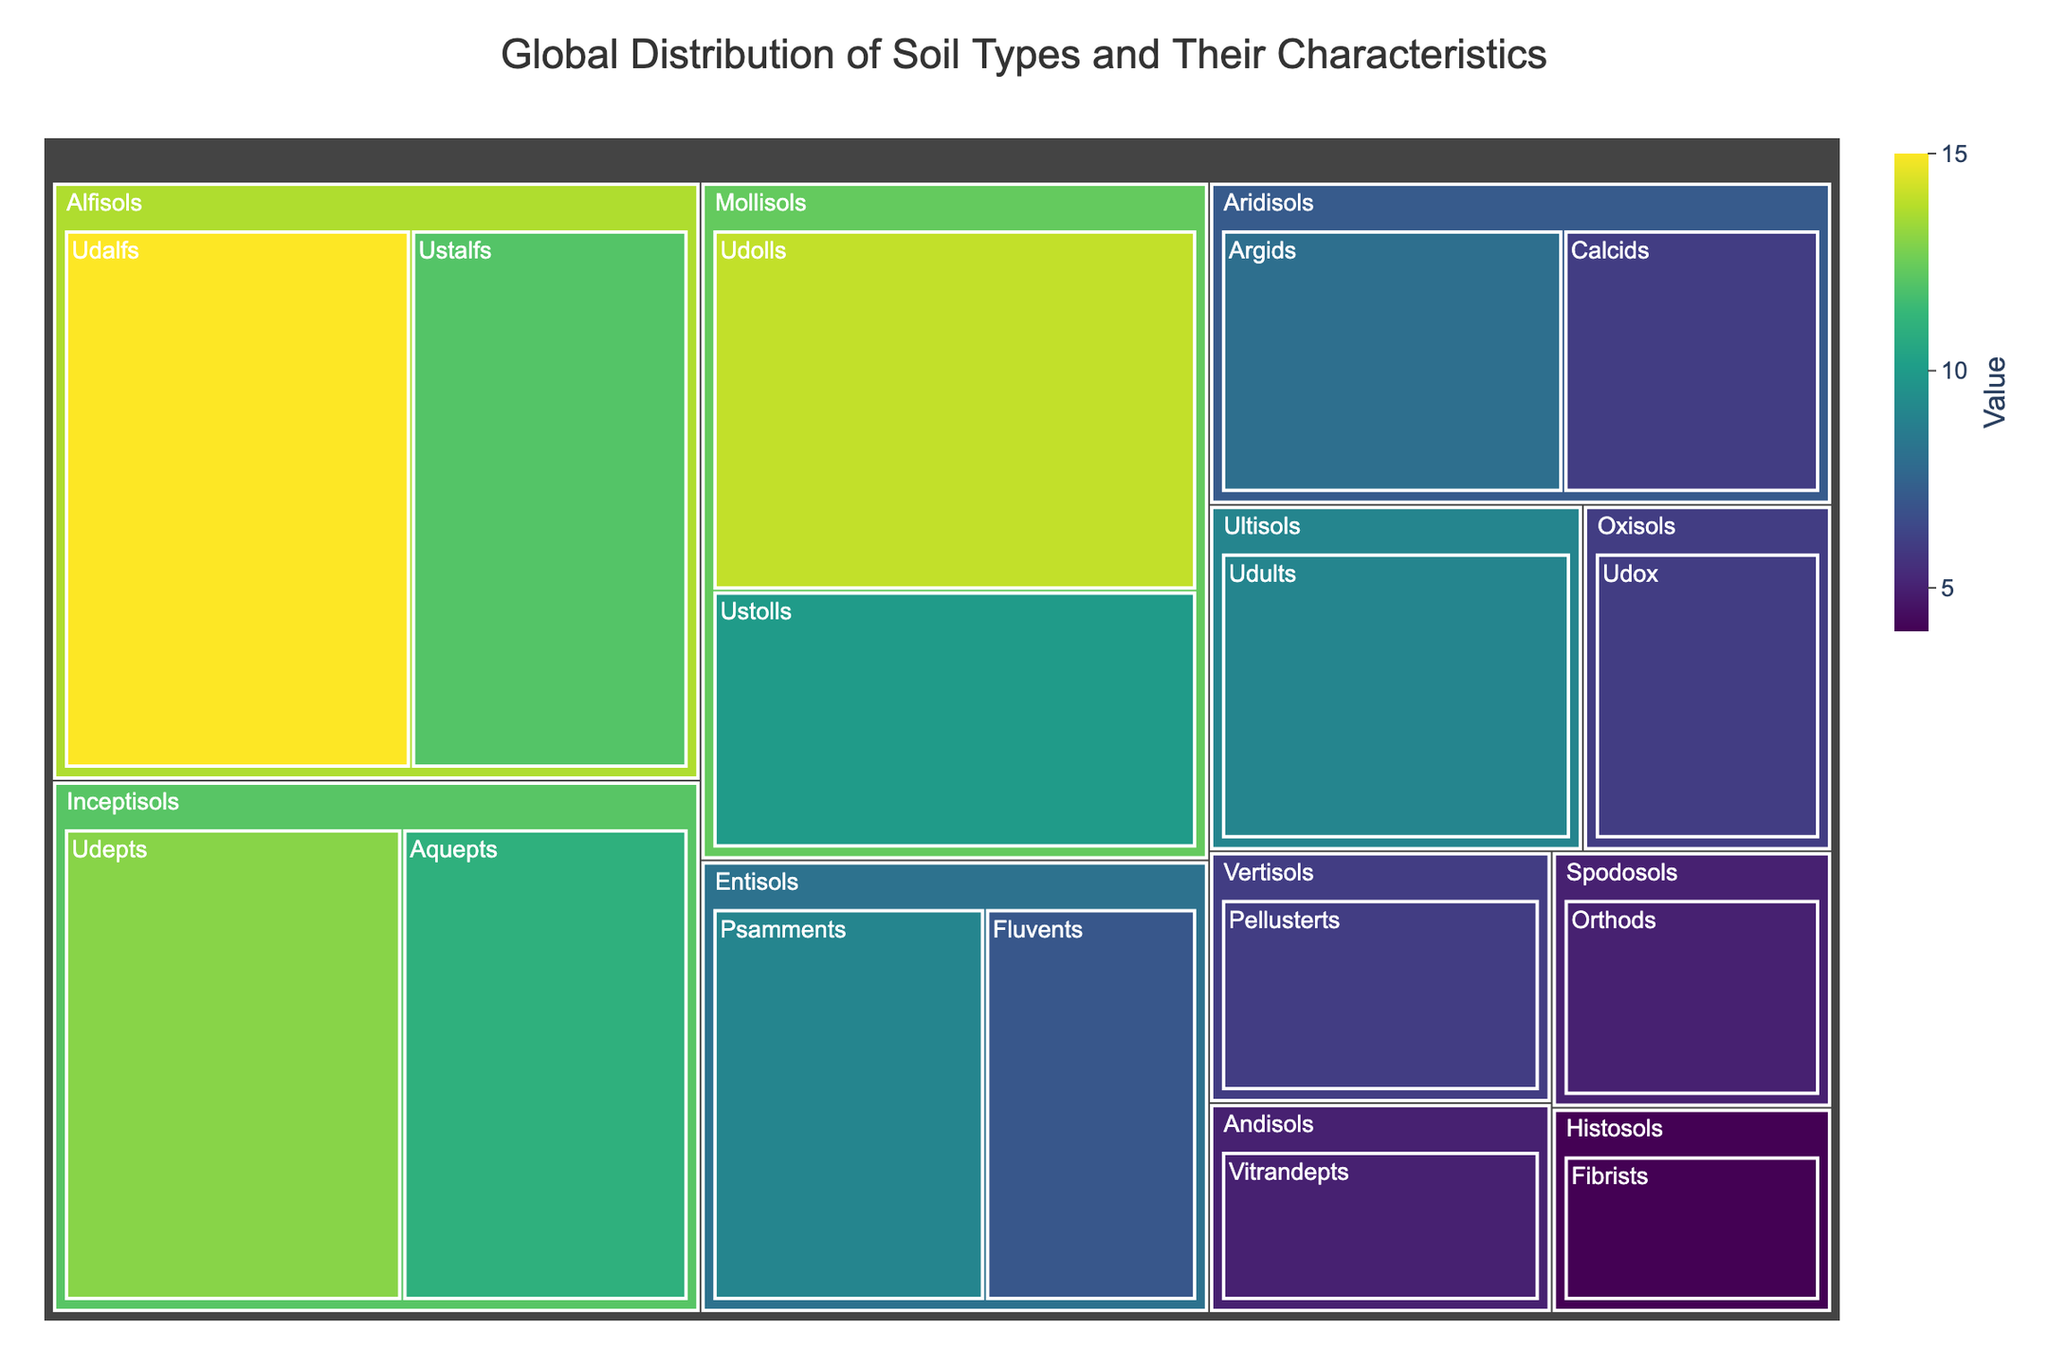What's the title of the treemap? The title of the treemap is usually prominently displayed at the top of the figure. Read the title directly from the figure.
Answer: Global Distribution of Soil Types and Their Characteristics Which soil category has the highest value? Each category is represented by a large colored section. Look for the largest section and note the value associated with it.
Answer: Alfisols How many subcategories does Mollisols have? Identify the section labeled "Mollisols" and count the number of smaller segments (subcategories) within it.
Answer: Two What is the total value for the Entisols category? Locate the subcategories under Entisols: Fluvents (7) and Psamments (9). Add these values together (7 + 9).
Answer: 16 What is the difference in value between the subcategories Udolls and Ustolls under Mollisols? Find the values for Udolls (14) and Ustolls (10). Subtract the smaller value from the larger value (14 - 10).
Answer: 4 Which subcategory of Aridisols has the higher value? Under the Aridisols category, compare the values for Argids and Calcids (8 and 6, respectively). Identify the larger value.
Answer: Argids What is the average value of the subcategories under Inceptisols? Locate the subcategories for Inceptisols: Aquepts (11) and Udepts (13). Add their values (11 + 13 = 24) and divide by the number of subcategories (2).
Answer: 12 Which soil category has more subcategories, Inceptisols or Alfisols? Count the number of subcategories under each: Inceptisols has 2 (Aquepts and Udepts) and Alfisols has 2 (Udalfs and Ustalfs).
Answer: They are equal Which subcategory has the smallest value, and what is that value? Compare the values of all subcategories in the treemap. Identify the smallest number.
Answer: Fibrists, 4 Explain the color coding in the treemap. The treemap uses color intensity to represent the value of each subcategory. Higher values are represented by more intense colors, while lower values are represented by lighter colors.
Answer: Intense colors for higher values, lighter colors for lower values 